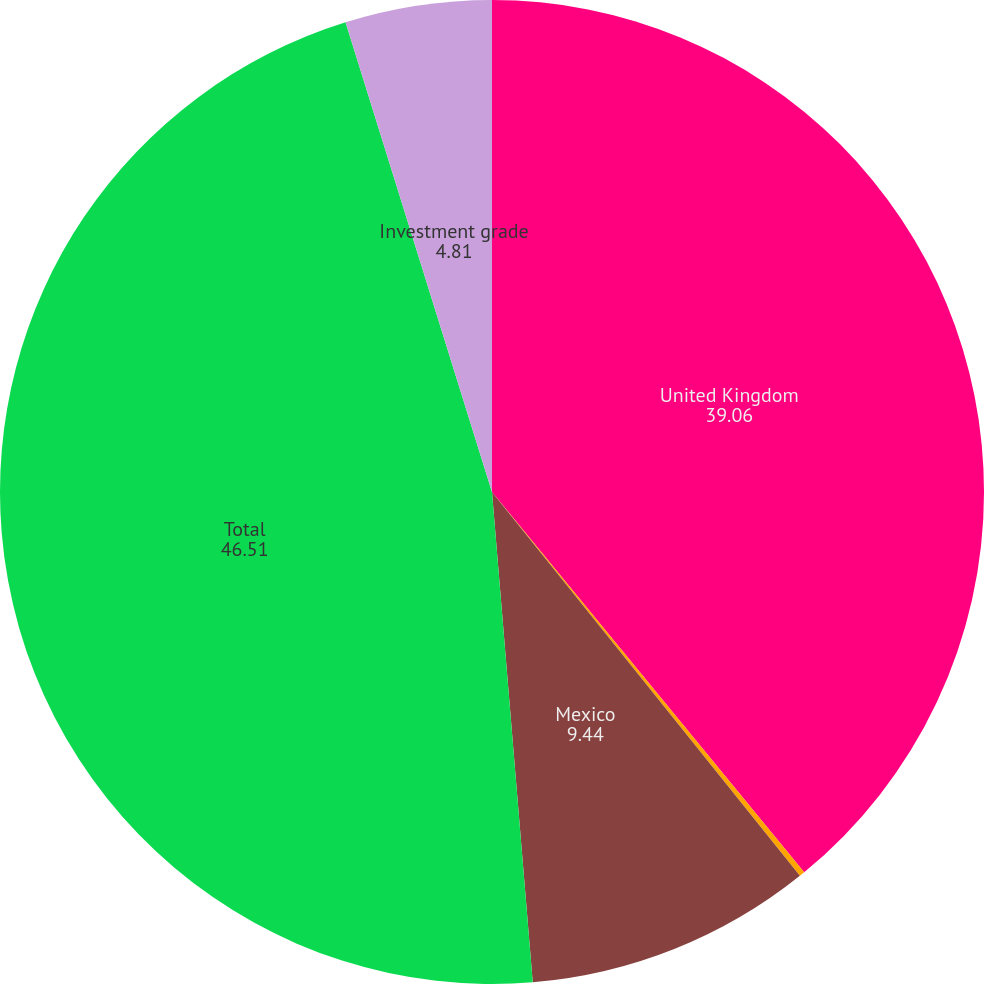<chart> <loc_0><loc_0><loc_500><loc_500><pie_chart><fcel>United Kingdom<fcel>South Korea<fcel>Mexico<fcel>Total<fcel>Investment grade<nl><fcel>39.06%<fcel>0.18%<fcel>9.44%<fcel>46.51%<fcel>4.81%<nl></chart> 